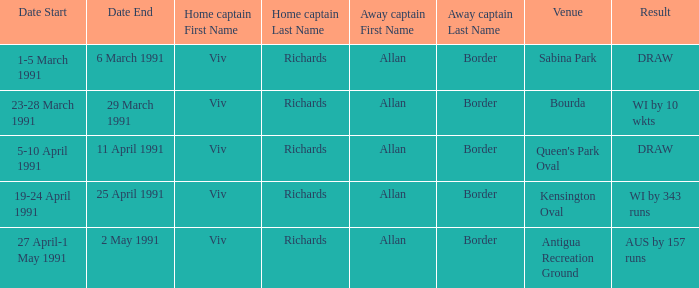What dates had matches at the venue Sabina Park? 1,2,3,5,6 March 1991. 